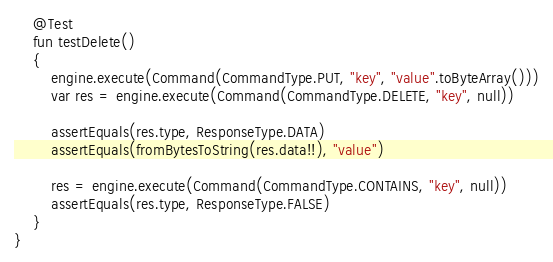<code> <loc_0><loc_0><loc_500><loc_500><_Kotlin_>
    @Test
    fun testDelete()
    {
        engine.execute(Command(CommandType.PUT, "key", "value".toByteArray()))
        var res = engine.execute(Command(CommandType.DELETE, "key", null))

        assertEquals(res.type, ResponseType.DATA)
        assertEquals(fromBytesToString(res.data!!), "value")

        res = engine.execute(Command(CommandType.CONTAINS, "key", null))
        assertEquals(res.type, ResponseType.FALSE)
    }
}
</code> 